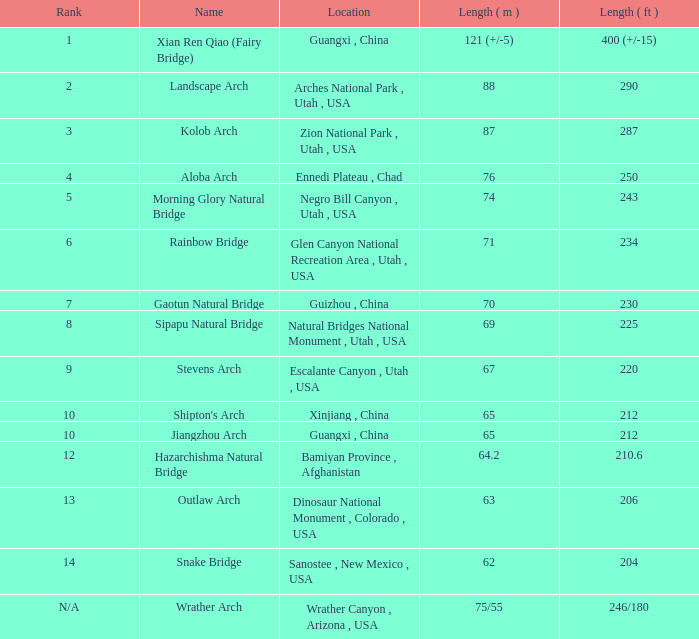What is the measurement in feet when the measurement in meters is 6 210.6. I'm looking to parse the entire table for insights. Could you assist me with that? {'header': ['Rank', 'Name', 'Location', 'Length ( m )', 'Length ( ft )'], 'rows': [['1', 'Xian Ren Qiao (Fairy Bridge)', 'Guangxi , China', '121 (+/-5)', '400 (+/-15)'], ['2', 'Landscape Arch', 'Arches National Park , Utah , USA', '88', '290'], ['3', 'Kolob Arch', 'Zion National Park , Utah , USA', '87', '287'], ['4', 'Aloba Arch', 'Ennedi Plateau , Chad', '76', '250'], ['5', 'Morning Glory Natural Bridge', 'Negro Bill Canyon , Utah , USA', '74', '243'], ['6', 'Rainbow Bridge', 'Glen Canyon National Recreation Area , Utah , USA', '71', '234'], ['7', 'Gaotun Natural Bridge', 'Guizhou , China', '70', '230'], ['8', 'Sipapu Natural Bridge', 'Natural Bridges National Monument , Utah , USA', '69', '225'], ['9', 'Stevens Arch', 'Escalante Canyon , Utah , USA', '67', '220'], ['10', "Shipton's Arch", 'Xinjiang , China', '65', '212'], ['10', 'Jiangzhou Arch', 'Guangxi , China', '65', '212'], ['12', 'Hazarchishma Natural Bridge', 'Bamiyan Province , Afghanistan', '64.2', '210.6'], ['13', 'Outlaw Arch', 'Dinosaur National Monument , Colorado , USA', '63', '206'], ['14', 'Snake Bridge', 'Sanostee , New Mexico , USA', '62', '204'], ['N/A', 'Wrather Arch', 'Wrather Canyon , Arizona , USA', '75/55', '246/180']]} 